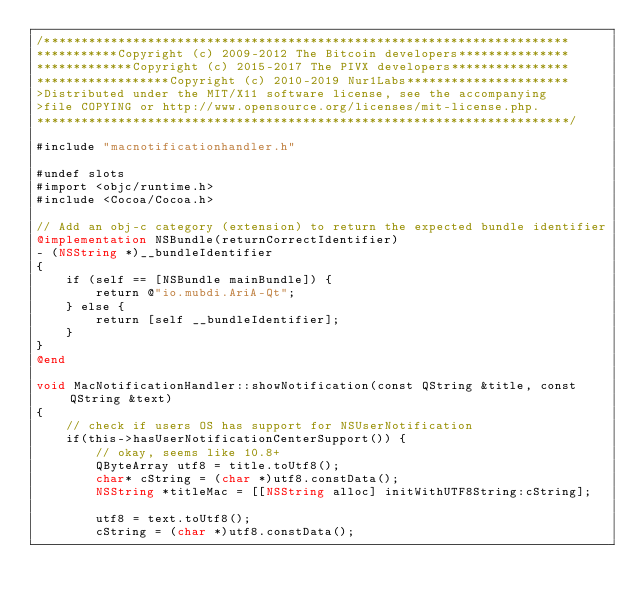Convert code to text. <code><loc_0><loc_0><loc_500><loc_500><_ObjectiveC_>/***********************************************************************
***********Copyright (c) 2009-2012 The Bitcoin developers***************
*************Copyright (c) 2015-2017 The PIVX developers****************
******************Copyright (c) 2010-2019 Nur1Labs**********************
>Distributed under the MIT/X11 software license, see the accompanying
>file COPYING or http://www.opensource.org/licenses/mit-license.php.
************************************************************************/

#include "macnotificationhandler.h"

#undef slots
#import <objc/runtime.h>
#include <Cocoa/Cocoa.h>

// Add an obj-c category (extension) to return the expected bundle identifier
@implementation NSBundle(returnCorrectIdentifier)
- (NSString *)__bundleIdentifier
{
    if (self == [NSBundle mainBundle]) {
        return @"io.mubdi.AriA-Qt";
    } else {
        return [self __bundleIdentifier];
    }
}
@end

void MacNotificationHandler::showNotification(const QString &title, const QString &text)
{
    // check if users OS has support for NSUserNotification
    if(this->hasUserNotificationCenterSupport()) {
        // okay, seems like 10.8+
        QByteArray utf8 = title.toUtf8();
        char* cString = (char *)utf8.constData();
        NSString *titleMac = [[NSString alloc] initWithUTF8String:cString];

        utf8 = text.toUtf8();
        cString = (char *)utf8.constData();</code> 